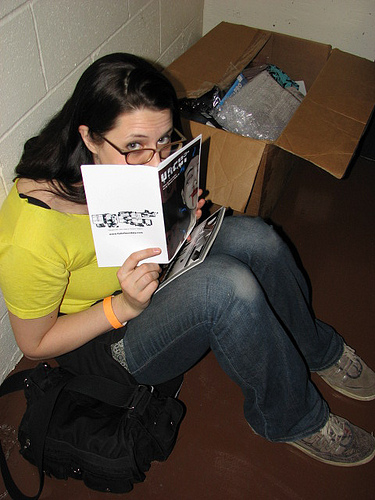<image>
Is there a box to the right of the girl? No. The box is not to the right of the girl. The horizontal positioning shows a different relationship. 